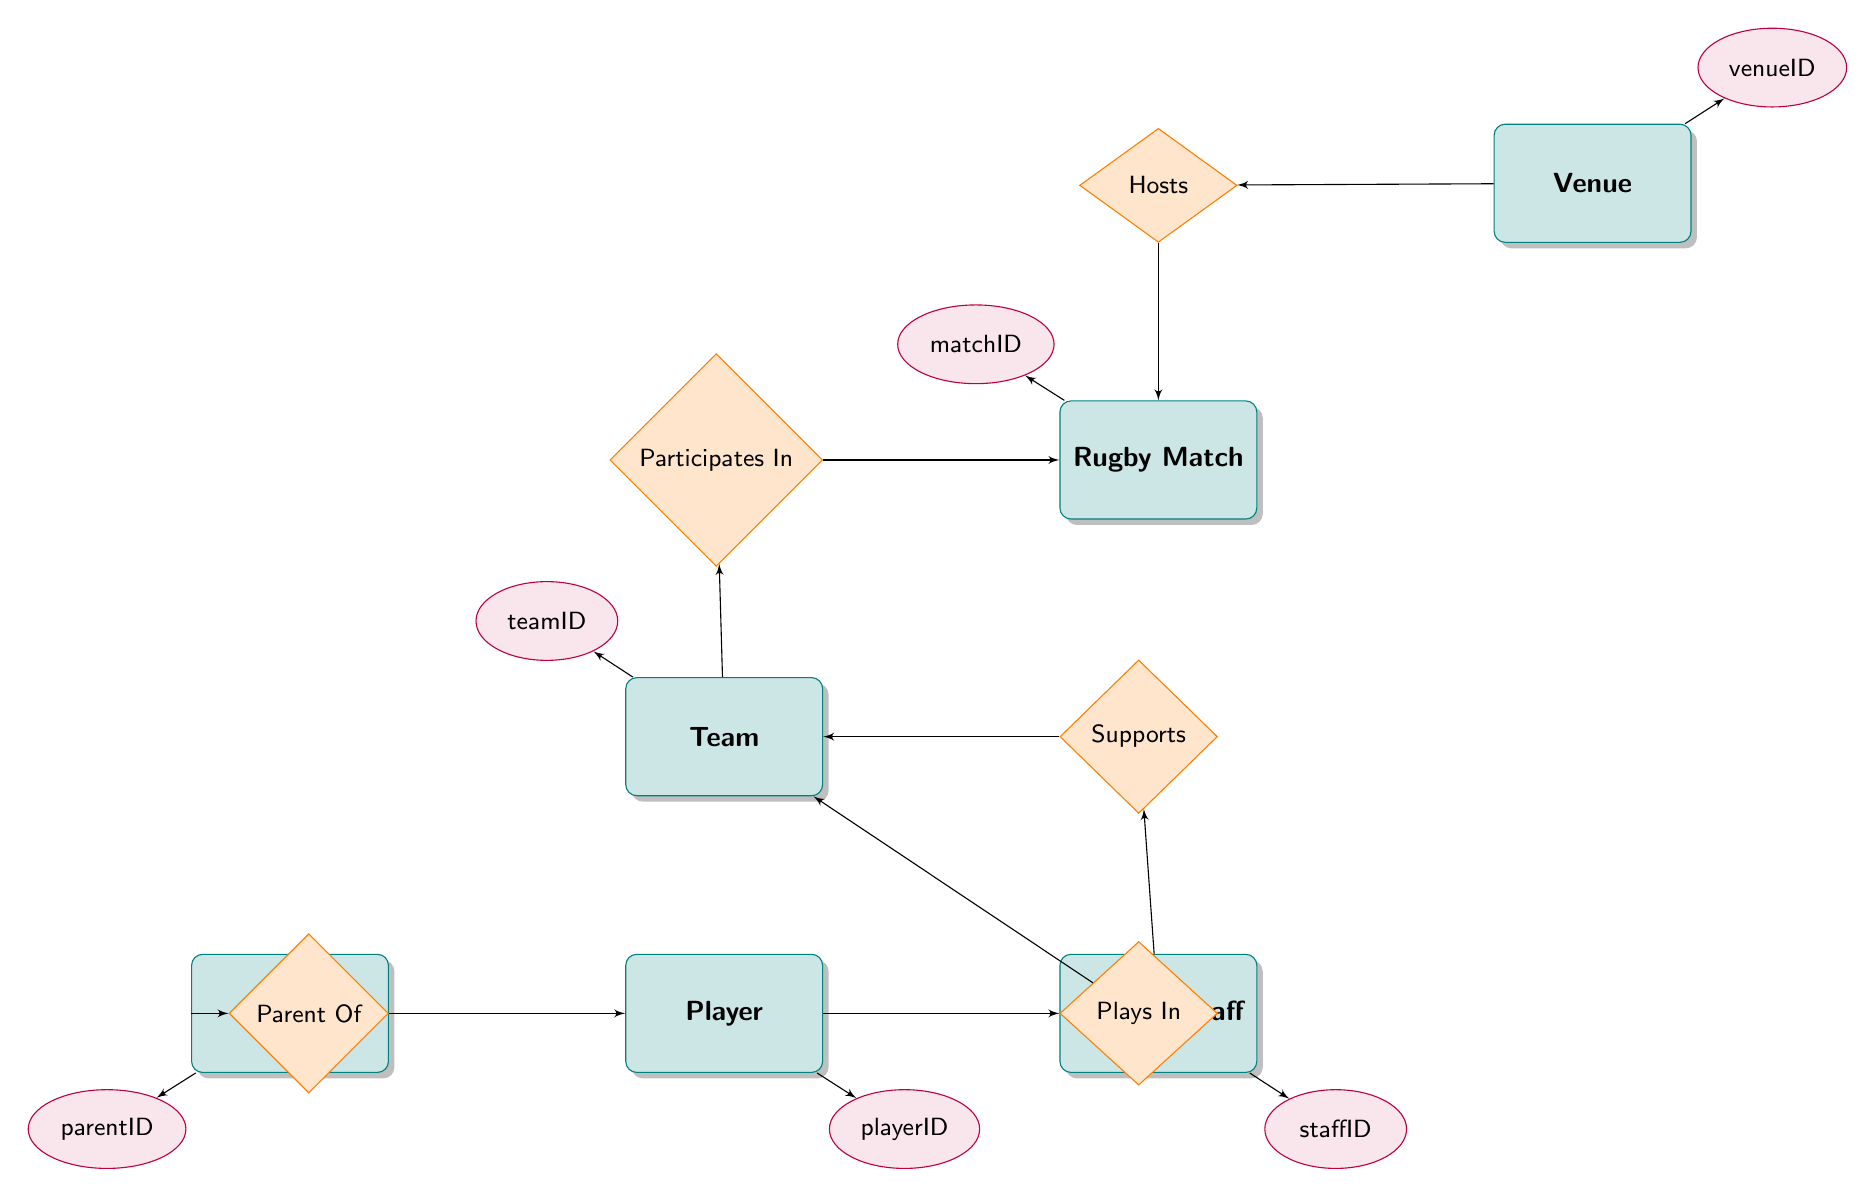what are the attributes of the Rugby Match entity? The Rugby Match entity has three attributes: matchID, date, and time. These attributes provide key information regarding each match.
Answer: matchID, date, time how many entities are present in the diagram? The diagram includes six entities: Rugby Match, Team, Venue, Support Staff, Parent, and Player. Counting these entities gives the total number of entities in the diagram.
Answer: 6 which team participates in the Rugby Match? The relationship "Participates In" connects Team to Rugby Match, indicating that any team that has this relationship is one of the teams participating in the match.
Answer: Team what role does Support Staff have in relation to Team? The "Supports" relationship connects Support Staff to Team. This indicates that Support Staff assists the Team in some capacity, which is essential for their performance.
Answer: Supports how many relationships are there involving the Team entity? The Team entity is involved in three relationships: "Participates In" (with Rugby Match), "Supports" (with Support Staff), and "Plays In" (with Player). Counting these relationships gives the total related to Team.
Answer: 3 which entity is connected to Venue through the Hosts relationship? The diagram shows that the Venue entity hosts the Rugby Match entity through the "Hosts" relationship. This indicates Venue's role in providing the location for the match.
Answer: Rugby Match who is identified as the Parent of the Player? The "Parent Of" relationship links Parent to Player, indicating the relationship between them, where a Parent has one or more Players associated with them.
Answer: Player what is the purpose of the relationship 'Plays In'? The 'Plays In' relationship denotes that a Player belongs to a particular Team. This helps identify which team the player is a part of during matches.
Answer: Team what are the attributes of the Support Staff entity? The Support Staff entity has three attributes: staffID, name, and role. These attributes describe each support staff member's unique identifier and their function.
Answer: staffID, name, role 